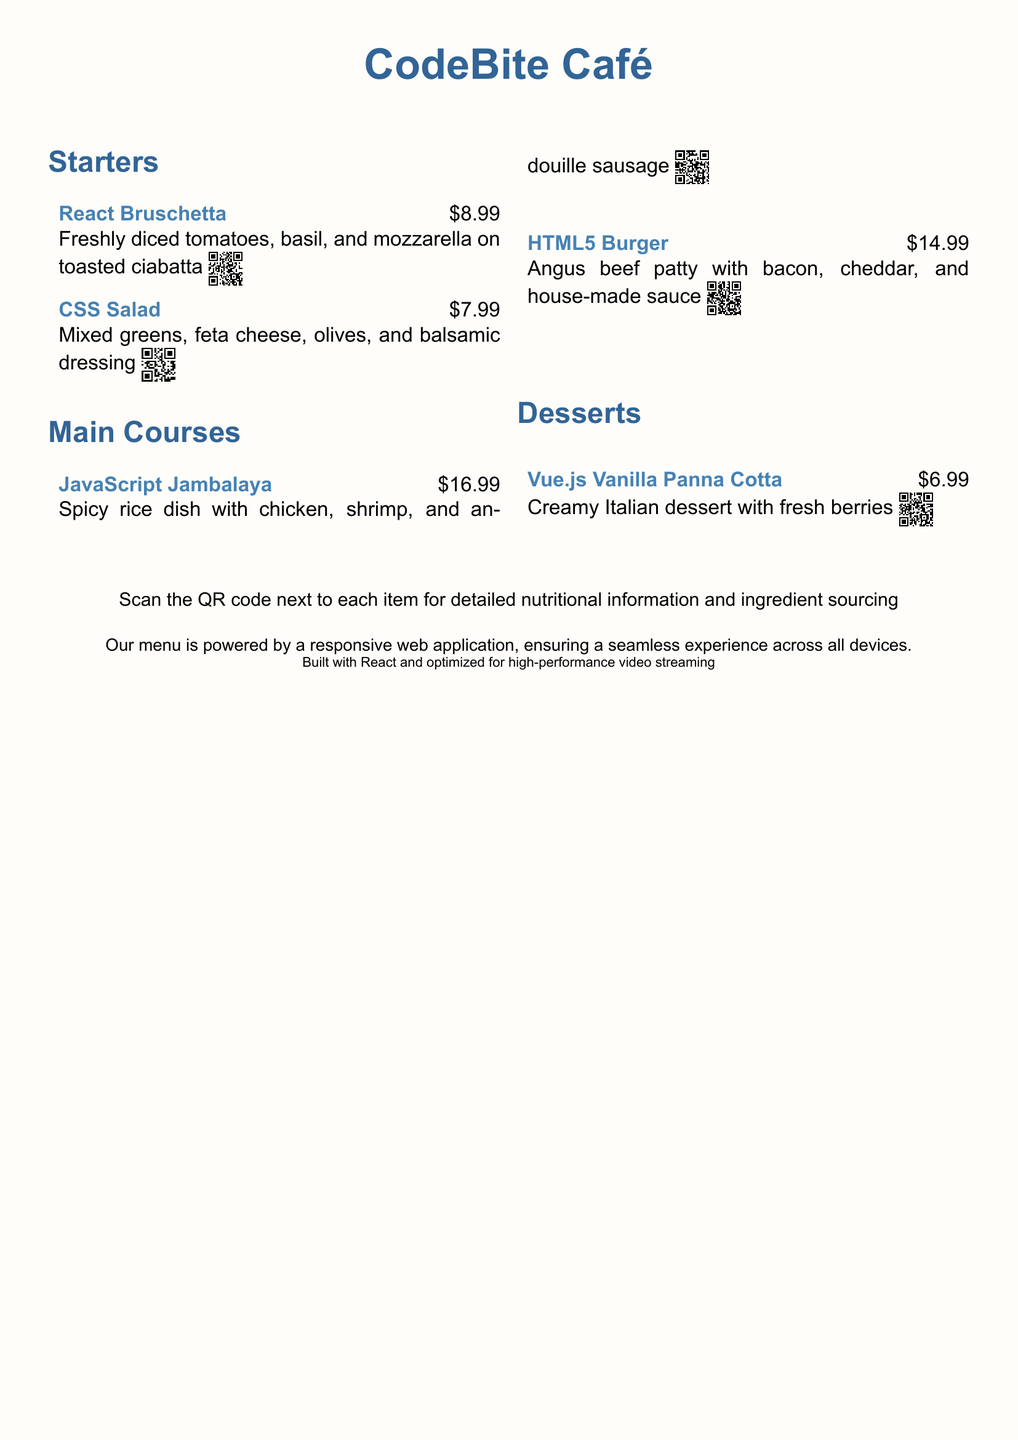what is the price of the React Bruschetta? The price of the React Bruschetta is indicated right next to the item in the menu.
Answer: $8.99 how many desserts are listed on the menu? The menu contains a section for desserts, and counting the items will give the total.
Answer: 1 what is the main ingredient in the JavaScript Jambalaya? The JavaScript Jambalaya is described and mentions its main components, which are chicken, shrimp, and sausage.
Answer: chicken, shrimp, and sausage which dish has a QR code for nutritional information? All main items in the menu provide QR codes for scanning next to their descriptions.
Answer: all dishes what kind of greens are included in the CSS Salad? The CSS Salad includes mixed greens that are specified in the description of the dish.
Answer: mixed greens what is the total price for all starters? The total price can be calculated by adding the prices of all starter items listed in the menu.
Answer: $16.98 which dessert is priced the lowest? The lowest-priced dessert is found by comparing the prices indicated next to the dessert items.
Answer: Vue.js Vanilla Panna Cotta what is the color theme of the menu? The document describes specific colors that are used for the background and headers, giving us insights about the design.
Answer: pastel color theme 